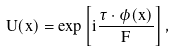Convert formula to latex. <formula><loc_0><loc_0><loc_500><loc_500>U ( x ) = \exp \left [ i \frac { \vec { \tau } \cdot \vec { \phi } ( x ) } { F } \right ] ,</formula> 